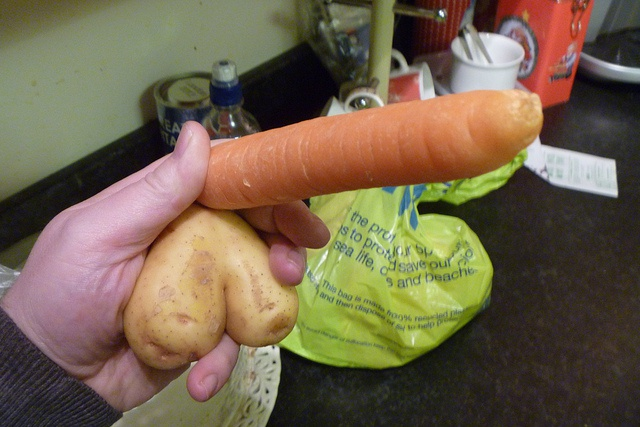Describe the objects in this image and their specific colors. I can see people in darkgreen, gray, black, and lightpink tones, carrot in darkgreen, tan, brown, salmon, and maroon tones, cup in darkgreen, lightgray, darkgray, and gray tones, and bottle in darkgreen, black, gray, and maroon tones in this image. 